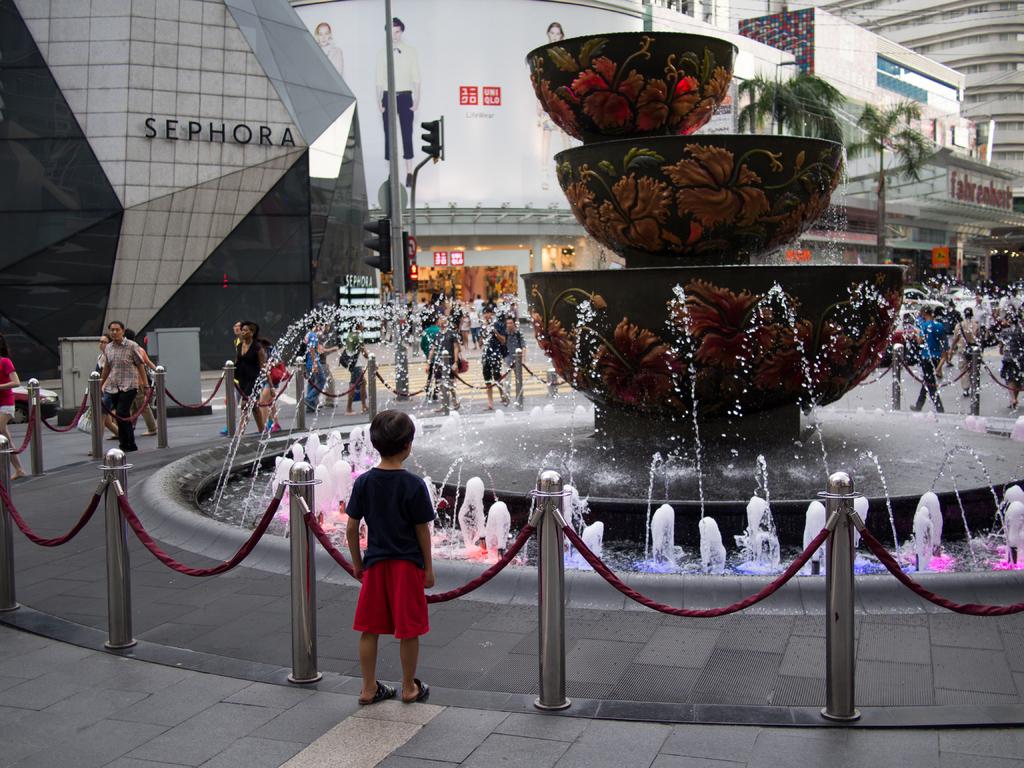What name is displayed on the building on the left?
Provide a succinct answer. Sephora. What store's name is in black letters on the building?
Give a very brief answer. Sephora. 